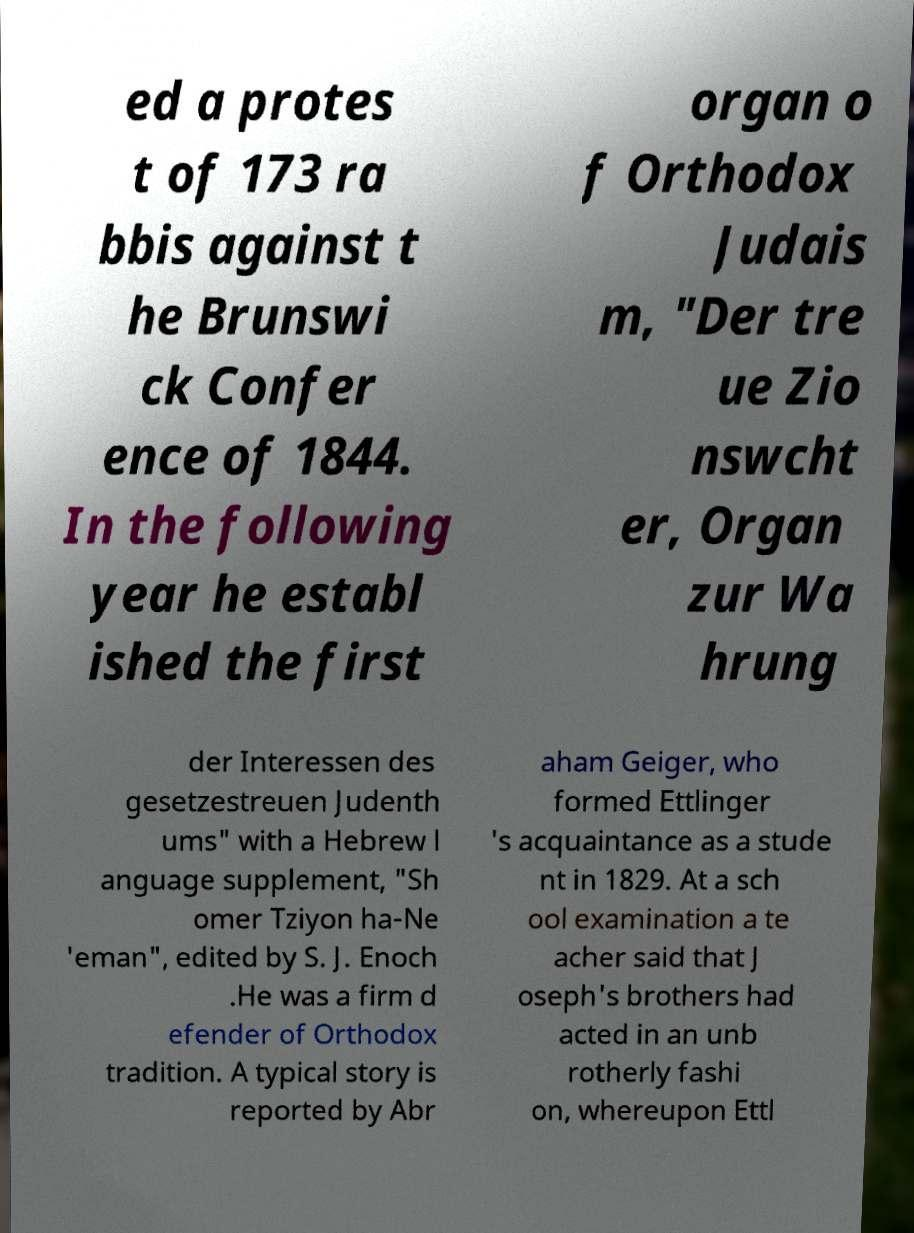Please read and relay the text visible in this image. What does it say? ed a protes t of 173 ra bbis against t he Brunswi ck Confer ence of 1844. In the following year he establ ished the first organ o f Orthodox Judais m, "Der tre ue Zio nswcht er, Organ zur Wa hrung der Interessen des gesetzestreuen Judenth ums" with a Hebrew l anguage supplement, "Sh omer Tziyon ha-Ne 'eman", edited by S. J. Enoch .He was a firm d efender of Orthodox tradition. A typical story is reported by Abr aham Geiger, who formed Ettlinger 's acquaintance as a stude nt in 1829. At a sch ool examination a te acher said that J oseph's brothers had acted in an unb rotherly fashi on, whereupon Ettl 